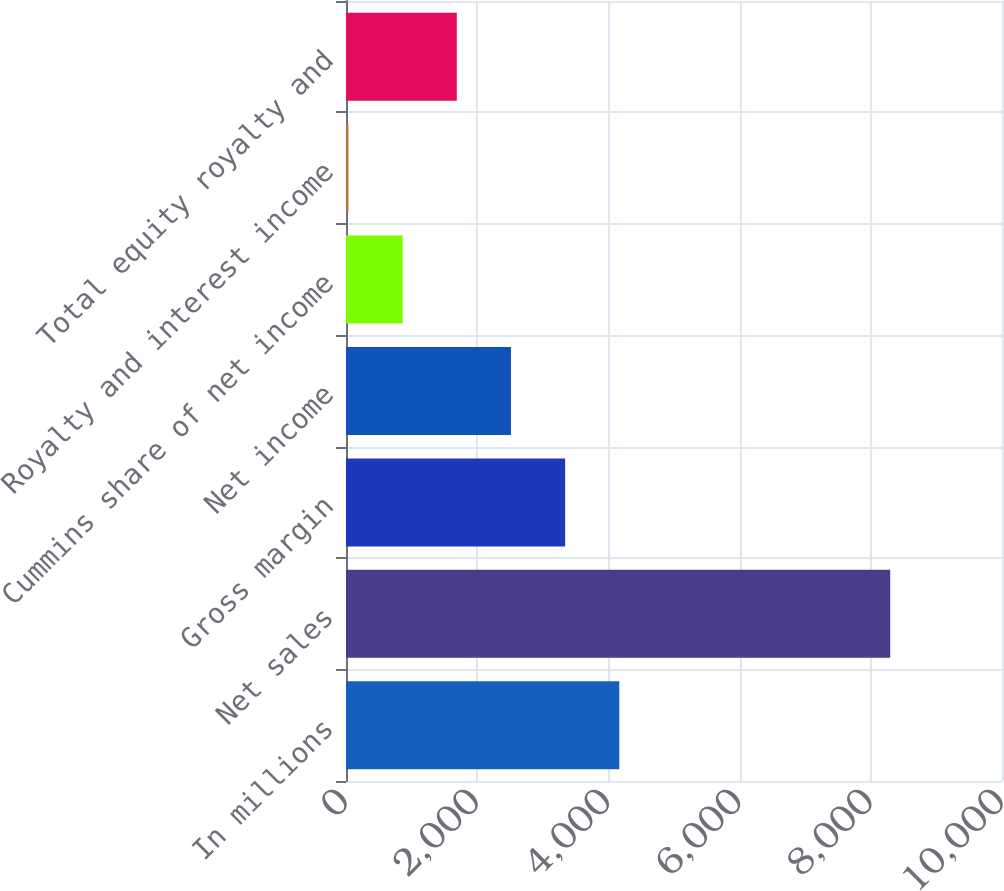Convert chart to OTSL. <chart><loc_0><loc_0><loc_500><loc_500><bar_chart><fcel>In millions<fcel>Net sales<fcel>Gross margin<fcel>Net income<fcel>Cummins share of net income<fcel>Royalty and interest income<fcel>Total equity royalty and<nl><fcel>4166.5<fcel>8296<fcel>3340.6<fcel>2514.7<fcel>862.9<fcel>37<fcel>1688.8<nl></chart> 